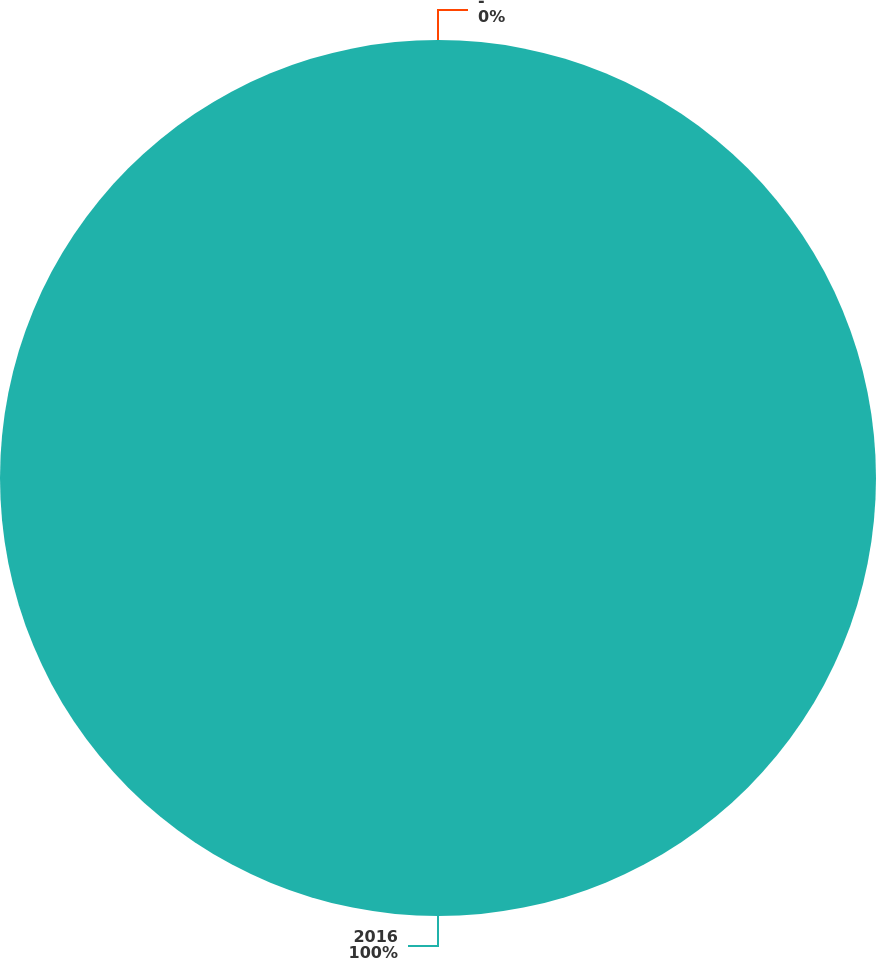<chart> <loc_0><loc_0><loc_500><loc_500><pie_chart><fcel>2016<fcel>-<nl><fcel>100.0%<fcel>0.0%<nl></chart> 